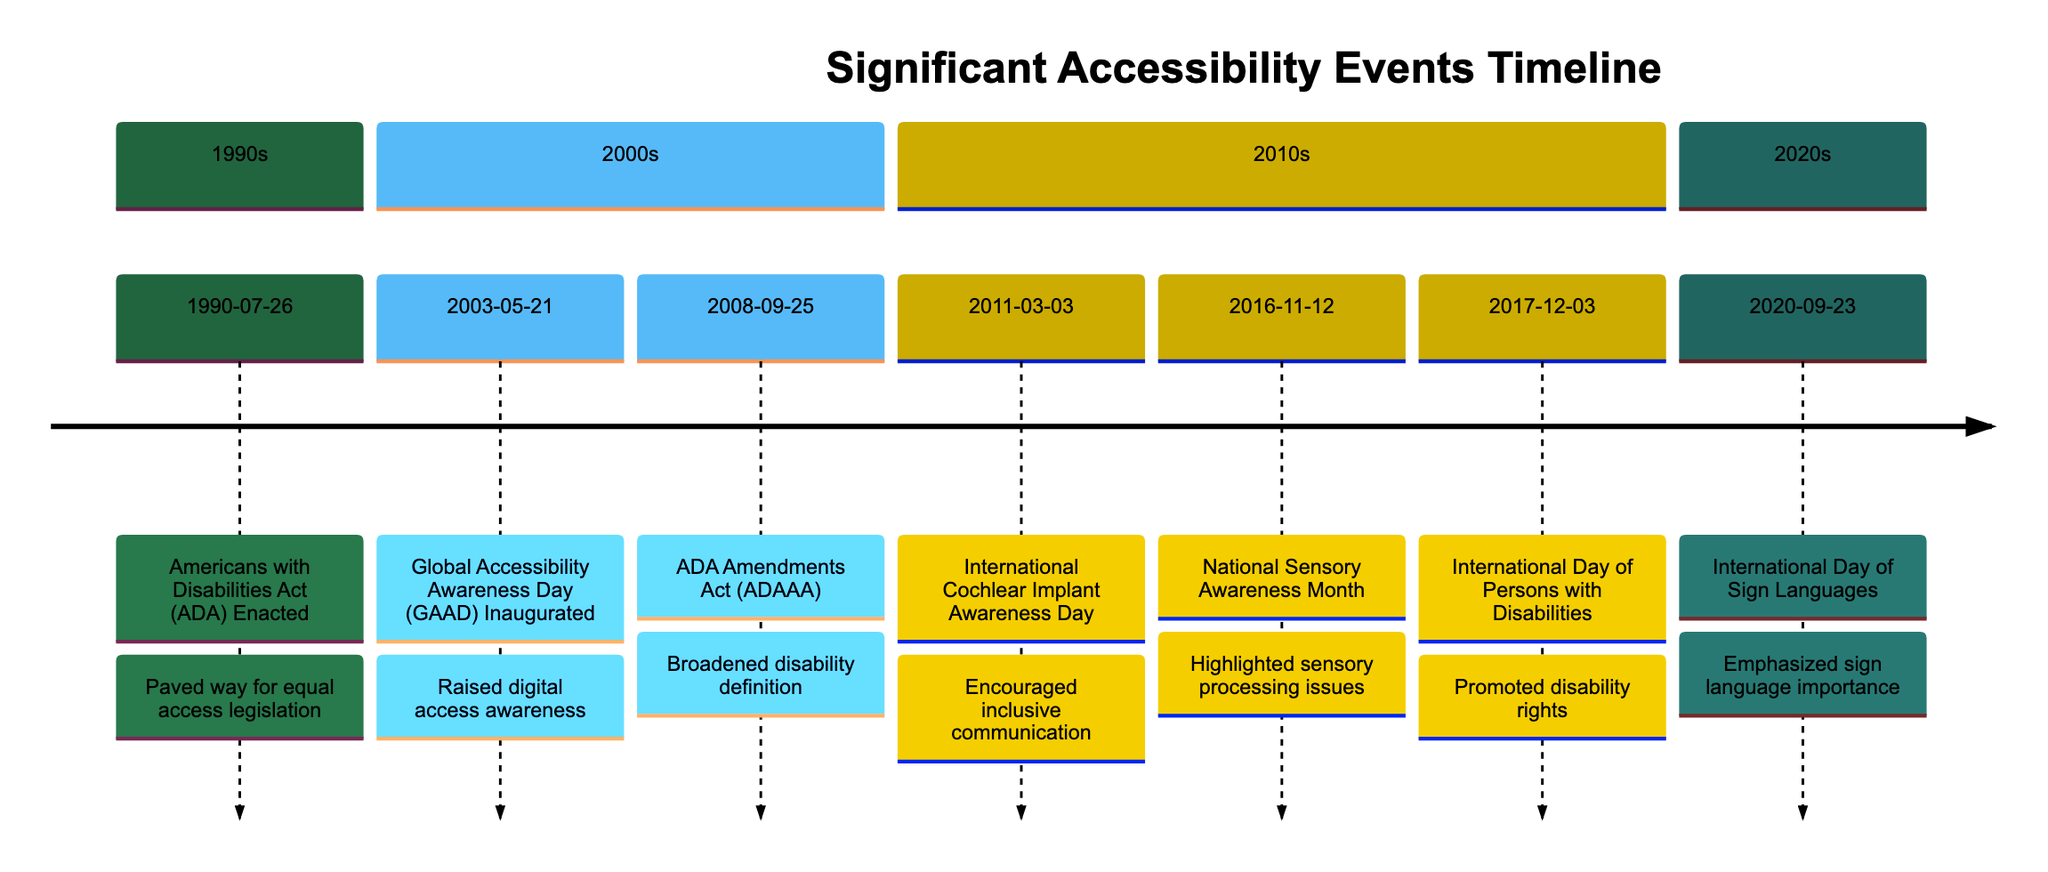What event was enacted on July 26, 1990? The diagram indicates that the "Americans with Disabilities Act (ADA)" was enacted on this date. The event is clearly identified with its corresponding date.
Answer: Americans with Disabilities Act (ADA) What is the significance of the date September 23, 2020? According to the timeline, this date marks the "International Day of Sign Languages," which emphasizes the importance of sign language for the deaf community.
Answer: International Day of Sign Languages How many significant events are listed in the timeline? Counting all the events from the timeline data provided, there are seven events mentioned in total, covering various years and themes related to accessibility.
Answer: 7 Which event in the 2010s highlighted sensory processing issues? The timeline specifies "National Sensory Awareness Month" on November 12, 2016, as the event that highlighted the importance of sensory processing issues.
Answer: National Sensory Awareness Month Which two events are focused on raising awareness for disability rights? The "ADA Amendments Act (ADAAA)" and "International Day of Persons with Disabilities" both serve to promote understanding and rights for individuals with disabilities as indicated by their impact statements on the timeline.
Answer: ADA Amendments Act (ADAAA), International Day of Persons with Disabilities Which event broadened the definition of disability? The timeline entry for "ADA Amendments Act (ADAAA)" on September 25, 2008, states that it broadened the definition of disability, ensuring more individuals are covered under the law.
Answer: ADA Amendments Act (ADAAA) What year marks the inauguration of Global Accessibility Awareness Day? The diagram indicates that Global Accessibility Awareness Day was inaugurated on May 21, 2003, as part of raising awareness for digital access.
Answer: 2003 How is the impact of the International Day of Sign Languages described? The timeline describes the impact of the International Day of Sign Languages as raising awareness about the essential role of sign language in achieving human rights for deaf people.
Answer: Raised awareness about the importance of sign language 